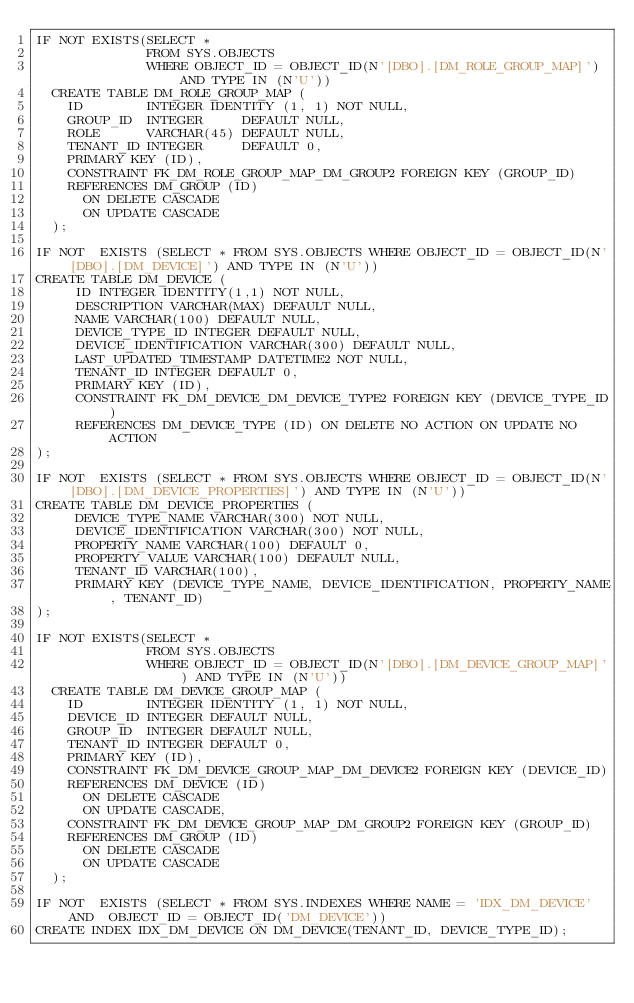Convert code to text. <code><loc_0><loc_0><loc_500><loc_500><_SQL_>IF NOT EXISTS(SELECT *
              FROM SYS.OBJECTS
              WHERE OBJECT_ID = OBJECT_ID(N'[DBO].[DM_ROLE_GROUP_MAP]') AND TYPE IN (N'U'))
  CREATE TABLE DM_ROLE_GROUP_MAP (
    ID        INTEGER IDENTITY (1, 1) NOT NULL,
    GROUP_ID  INTEGER     DEFAULT NULL,
    ROLE      VARCHAR(45) DEFAULT NULL,
    TENANT_ID INTEGER     DEFAULT 0,
    PRIMARY KEY (ID),
    CONSTRAINT FK_DM_ROLE_GROUP_MAP_DM_GROUP2 FOREIGN KEY (GROUP_ID)
    REFERENCES DM_GROUP (ID)
      ON DELETE CASCADE
      ON UPDATE CASCADE
  );

IF NOT  EXISTS (SELECT * FROM SYS.OBJECTS WHERE OBJECT_ID = OBJECT_ID(N'[DBO].[DM_DEVICE]') AND TYPE IN (N'U'))
CREATE TABLE DM_DEVICE (
     ID INTEGER IDENTITY(1,1) NOT NULL,
     DESCRIPTION VARCHAR(MAX) DEFAULT NULL,
     NAME VARCHAR(100) DEFAULT NULL,
     DEVICE_TYPE_ID INTEGER DEFAULT NULL,
     DEVICE_IDENTIFICATION VARCHAR(300) DEFAULT NULL,
     LAST_UPDATED_TIMESTAMP DATETIME2 NOT NULL,
     TENANT_ID INTEGER DEFAULT 0,
     PRIMARY KEY (ID),
     CONSTRAINT FK_DM_DEVICE_DM_DEVICE_TYPE2 FOREIGN KEY (DEVICE_TYPE_ID)
     REFERENCES DM_DEVICE_TYPE (ID) ON DELETE NO ACTION ON UPDATE NO ACTION
);

IF NOT  EXISTS (SELECT * FROM SYS.OBJECTS WHERE OBJECT_ID = OBJECT_ID(N'[DBO].[DM_DEVICE_PROPERTIES]') AND TYPE IN (N'U'))
CREATE TABLE DM_DEVICE_PROPERTIES (
     DEVICE_TYPE_NAME VARCHAR(300) NOT NULL,
     DEVICE_IDENTIFICATION VARCHAR(300) NOT NULL,
     PROPERTY_NAME VARCHAR(100) DEFAULT 0,
     PROPERTY_VALUE VARCHAR(100) DEFAULT NULL,
     TENANT_ID VARCHAR(100),
     PRIMARY KEY (DEVICE_TYPE_NAME, DEVICE_IDENTIFICATION, PROPERTY_NAME, TENANT_ID)
);

IF NOT EXISTS(SELECT *
              FROM SYS.OBJECTS
              WHERE OBJECT_ID = OBJECT_ID(N'[DBO].[DM_DEVICE_GROUP_MAP]') AND TYPE IN (N'U'))
  CREATE TABLE DM_DEVICE_GROUP_MAP (
    ID        INTEGER IDENTITY (1, 1) NOT NULL,
    DEVICE_ID INTEGER DEFAULT NULL,
    GROUP_ID  INTEGER DEFAULT NULL,
    TENANT_ID INTEGER DEFAULT 0,
    PRIMARY KEY (ID),
    CONSTRAINT FK_DM_DEVICE_GROUP_MAP_DM_DEVICE2 FOREIGN KEY (DEVICE_ID)
    REFERENCES DM_DEVICE (ID)
      ON DELETE CASCADE
      ON UPDATE CASCADE,
    CONSTRAINT FK_DM_DEVICE_GROUP_MAP_DM_GROUP2 FOREIGN KEY (GROUP_ID)
    REFERENCES DM_GROUP (ID)
      ON DELETE CASCADE
      ON UPDATE CASCADE
  );

IF NOT  EXISTS (SELECT * FROM SYS.INDEXES WHERE NAME = 'IDX_DM_DEVICE' AND  OBJECT_ID = OBJECT_ID('DM_DEVICE'))
CREATE INDEX IDX_DM_DEVICE ON DM_DEVICE(TENANT_ID, DEVICE_TYPE_ID);
</code> 